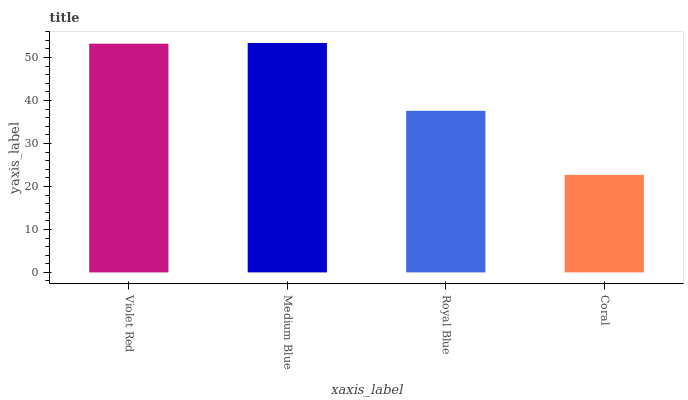Is Coral the minimum?
Answer yes or no. Yes. Is Medium Blue the maximum?
Answer yes or no. Yes. Is Royal Blue the minimum?
Answer yes or no. No. Is Royal Blue the maximum?
Answer yes or no. No. Is Medium Blue greater than Royal Blue?
Answer yes or no. Yes. Is Royal Blue less than Medium Blue?
Answer yes or no. Yes. Is Royal Blue greater than Medium Blue?
Answer yes or no. No. Is Medium Blue less than Royal Blue?
Answer yes or no. No. Is Violet Red the high median?
Answer yes or no. Yes. Is Royal Blue the low median?
Answer yes or no. Yes. Is Royal Blue the high median?
Answer yes or no. No. Is Coral the low median?
Answer yes or no. No. 